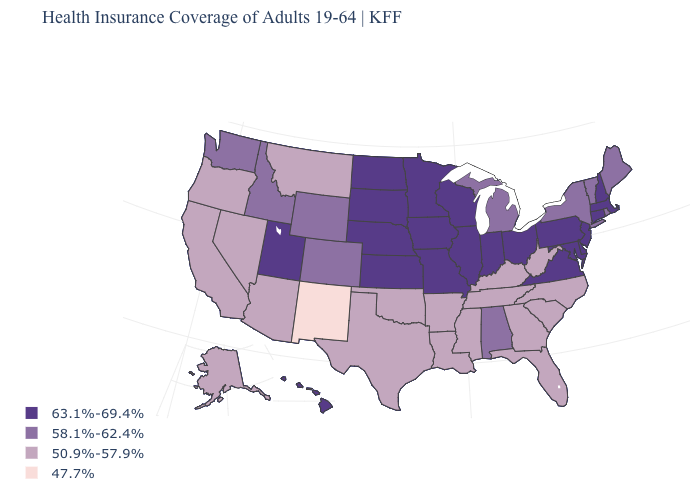Does Colorado have a lower value than Kansas?
Keep it brief. Yes. Name the states that have a value in the range 50.9%-57.9%?
Give a very brief answer. Alaska, Arizona, Arkansas, California, Florida, Georgia, Kentucky, Louisiana, Mississippi, Montana, Nevada, North Carolina, Oklahoma, Oregon, South Carolina, Tennessee, Texas, West Virginia. Does Minnesota have the same value as South Dakota?
Give a very brief answer. Yes. Is the legend a continuous bar?
Concise answer only. No. What is the value of Iowa?
Quick response, please. 63.1%-69.4%. Does North Carolina have a higher value than New Mexico?
Be succinct. Yes. What is the lowest value in the South?
Short answer required. 50.9%-57.9%. Name the states that have a value in the range 63.1%-69.4%?
Concise answer only. Connecticut, Delaware, Hawaii, Illinois, Indiana, Iowa, Kansas, Maryland, Massachusetts, Minnesota, Missouri, Nebraska, New Hampshire, New Jersey, North Dakota, Ohio, Pennsylvania, South Dakota, Utah, Virginia, Wisconsin. Does the first symbol in the legend represent the smallest category?
Quick response, please. No. Which states hav the highest value in the Northeast?
Keep it brief. Connecticut, Massachusetts, New Hampshire, New Jersey, Pennsylvania. Does Oklahoma have the lowest value in the USA?
Be succinct. No. Does Michigan have a higher value than Wyoming?
Write a very short answer. No. Among the states that border Florida , does Alabama have the highest value?
Be succinct. Yes. Does New Mexico have the highest value in the USA?
Be succinct. No. 